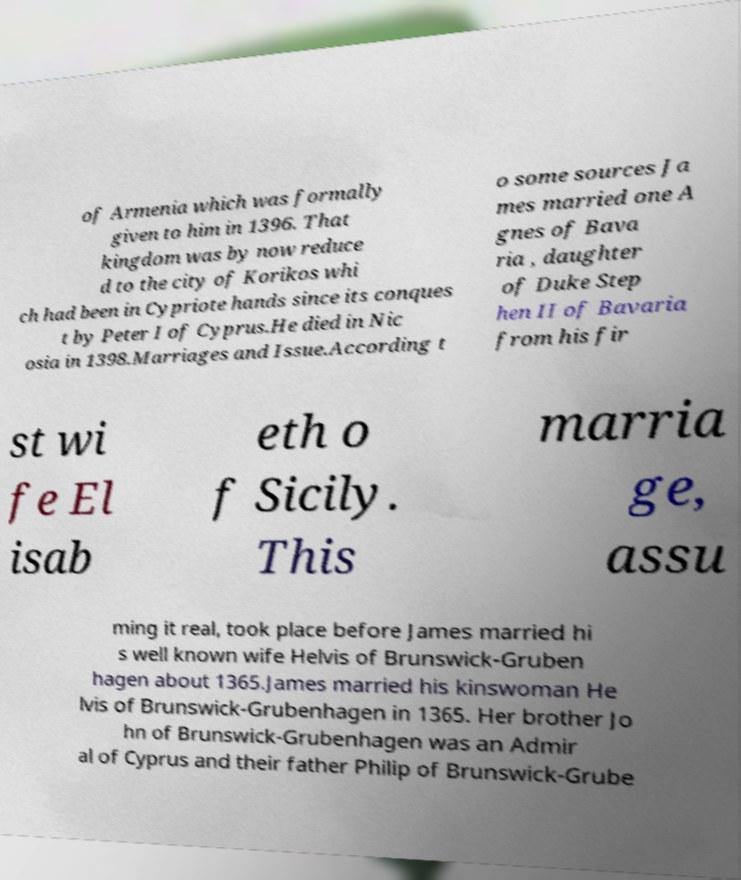Could you extract and type out the text from this image? of Armenia which was formally given to him in 1396. That kingdom was by now reduce d to the city of Korikos whi ch had been in Cypriote hands since its conques t by Peter I of Cyprus.He died in Nic osia in 1398.Marriages and Issue.According t o some sources Ja mes married one A gnes of Bava ria , daughter of Duke Step hen II of Bavaria from his fir st wi fe El isab eth o f Sicily. This marria ge, assu ming it real, took place before James married hi s well known wife Helvis of Brunswick-Gruben hagen about 1365.James married his kinswoman He lvis of Brunswick-Grubenhagen in 1365. Her brother Jo hn of Brunswick-Grubenhagen was an Admir al of Cyprus and their father Philip of Brunswick-Grube 